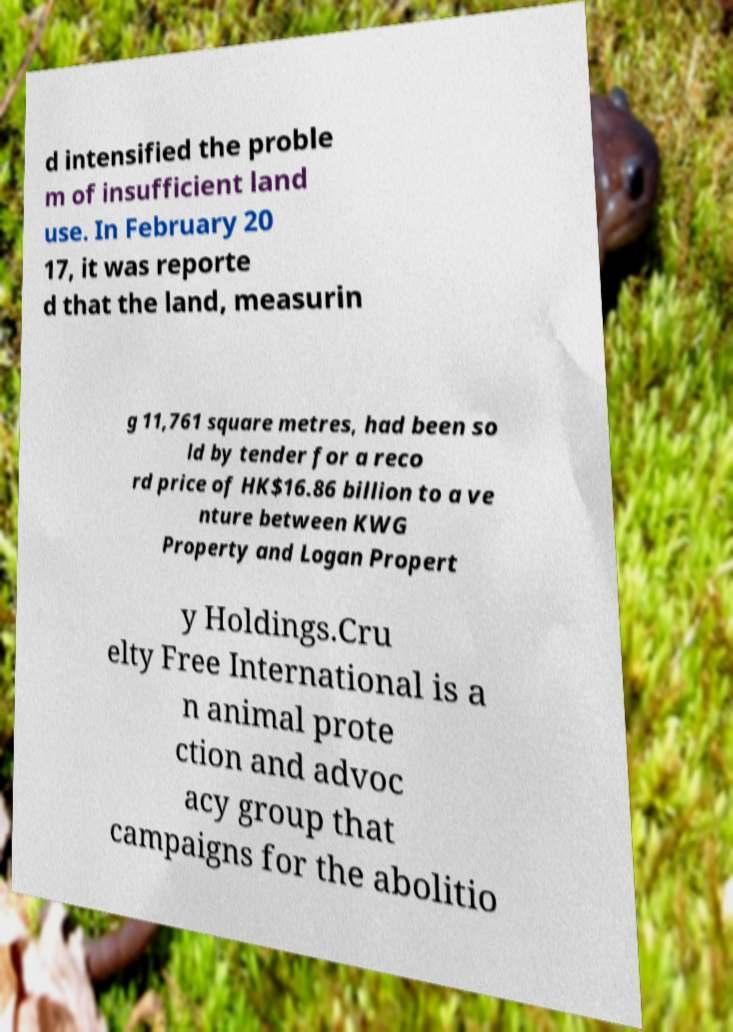Could you extract and type out the text from this image? d intensified the proble m of insufficient land use. In February 20 17, it was reporte d that the land, measurin g 11,761 square metres, had been so ld by tender for a reco rd price of HK$16.86 billion to a ve nture between KWG Property and Logan Propert y Holdings.Cru elty Free International is a n animal prote ction and advoc acy group that campaigns for the abolitio 